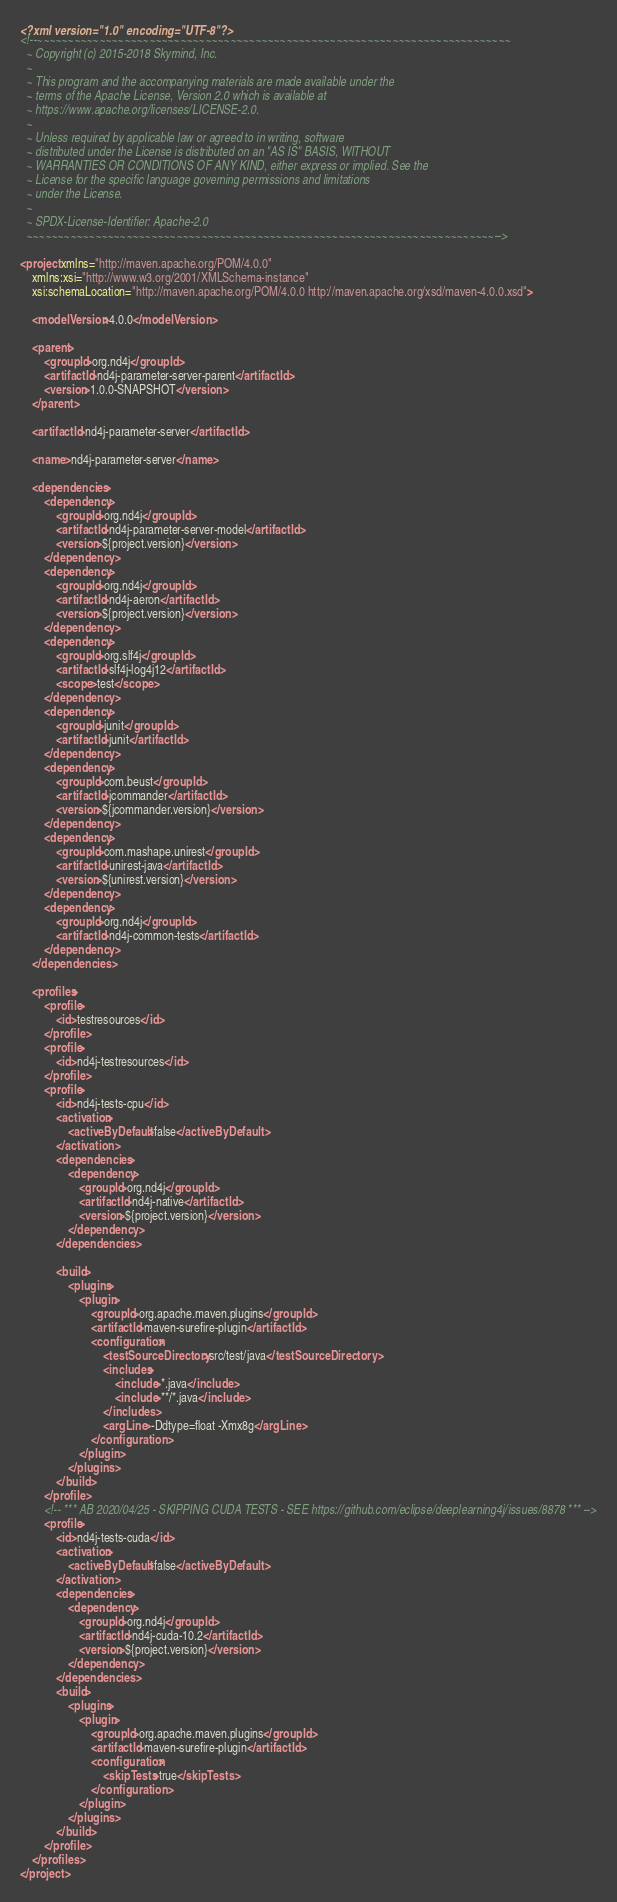Convert code to text. <code><loc_0><loc_0><loc_500><loc_500><_XML_><?xml version="1.0" encoding="UTF-8"?>
<!--~~~~~~~~~~~~~~~~~~~~~~~~~~~~~~~~~~~~~~~~~~~~~~~~~~~~~~~~~~~~~~~~~~~~~~~~~~~~
  ~ Copyright (c) 2015-2018 Skymind, Inc.
  ~
  ~ This program and the accompanying materials are made available under the
  ~ terms of the Apache License, Version 2.0 which is available at
  ~ https://www.apache.org/licenses/LICENSE-2.0.
  ~
  ~ Unless required by applicable law or agreed to in writing, software
  ~ distributed under the License is distributed on an "AS IS" BASIS, WITHOUT
  ~ WARRANTIES OR CONDITIONS OF ANY KIND, either express or implied. See the
  ~ License for the specific language governing permissions and limitations
  ~ under the License.
  ~
  ~ SPDX-License-Identifier: Apache-2.0
  ~~~~~~~~~~~~~~~~~~~~~~~~~~~~~~~~~~~~~~~~~~~~~~~~~~~~~~~~~~~~~~~~~~~~~~~~~~~-->

<project xmlns="http://maven.apache.org/POM/4.0.0"
    xmlns:xsi="http://www.w3.org/2001/XMLSchema-instance"
    xsi:schemaLocation="http://maven.apache.org/POM/4.0.0 http://maven.apache.org/xsd/maven-4.0.0.xsd">

    <modelVersion>4.0.0</modelVersion>

    <parent>
        <groupId>org.nd4j</groupId>
        <artifactId>nd4j-parameter-server-parent</artifactId>
        <version>1.0.0-SNAPSHOT</version>
    </parent>

    <artifactId>nd4j-parameter-server</artifactId>

    <name>nd4j-parameter-server</name>

    <dependencies>
        <dependency>
            <groupId>org.nd4j</groupId>
            <artifactId>nd4j-parameter-server-model</artifactId>
            <version>${project.version}</version>
        </dependency>
        <dependency>
            <groupId>org.nd4j</groupId>
            <artifactId>nd4j-aeron</artifactId>
            <version>${project.version}</version>
        </dependency>
        <dependency>
            <groupId>org.slf4j</groupId>
            <artifactId>slf4j-log4j12</artifactId>
            <scope>test</scope>
        </dependency>
        <dependency>
            <groupId>junit</groupId>
            <artifactId>junit</artifactId>
        </dependency>
        <dependency>
            <groupId>com.beust</groupId>
            <artifactId>jcommander</artifactId>
            <version>${jcommander.version}</version>
        </dependency>
        <dependency>
            <groupId>com.mashape.unirest</groupId>
            <artifactId>unirest-java</artifactId>
            <version>${unirest.version}</version>
        </dependency>
        <dependency>
            <groupId>org.nd4j</groupId>
            <artifactId>nd4j-common-tests</artifactId>
        </dependency>
    </dependencies>

    <profiles>
        <profile>
            <id>testresources</id>
        </profile>
        <profile>
            <id>nd4j-testresources</id>
        </profile>
        <profile>
            <id>nd4j-tests-cpu</id>
            <activation>
                <activeByDefault>false</activeByDefault>
            </activation>
            <dependencies>
                <dependency>
                    <groupId>org.nd4j</groupId>
                    <artifactId>nd4j-native</artifactId>
                    <version>${project.version}</version>
                </dependency>
            </dependencies>

            <build>
                <plugins>
                    <plugin>
                        <groupId>org.apache.maven.plugins</groupId>
                        <artifactId>maven-surefire-plugin</artifactId>
                        <configuration>
                            <testSourceDirectory>src/test/java</testSourceDirectory>
                            <includes>
                                <include>*.java</include>
                                <include>**/*.java</include>
                            </includes>
                            <argLine>-Ddtype=float -Xmx8g</argLine>
                        </configuration>
                    </plugin>
                </plugins>
            </build>
        </profile>
        <!-- *** AB 2020/04/25 - SKIPPING CUDA TESTS - SEE https://github.com/eclipse/deeplearning4j/issues/8878 *** -->
        <profile>
            <id>nd4j-tests-cuda</id>
            <activation>
                <activeByDefault>false</activeByDefault>
            </activation>
            <dependencies>
                <dependency>
                    <groupId>org.nd4j</groupId>
                    <artifactId>nd4j-cuda-10.2</artifactId>
                    <version>${project.version}</version>
                </dependency>
            </dependencies>
            <build>
                <plugins>
                    <plugin>
                        <groupId>org.apache.maven.plugins</groupId>
                        <artifactId>maven-surefire-plugin</artifactId>
                        <configuration>
                            <skipTests>true</skipTests>
                        </configuration>
                    </plugin>
                </plugins>
            </build>
        </profile>
    </profiles>
</project>
</code> 